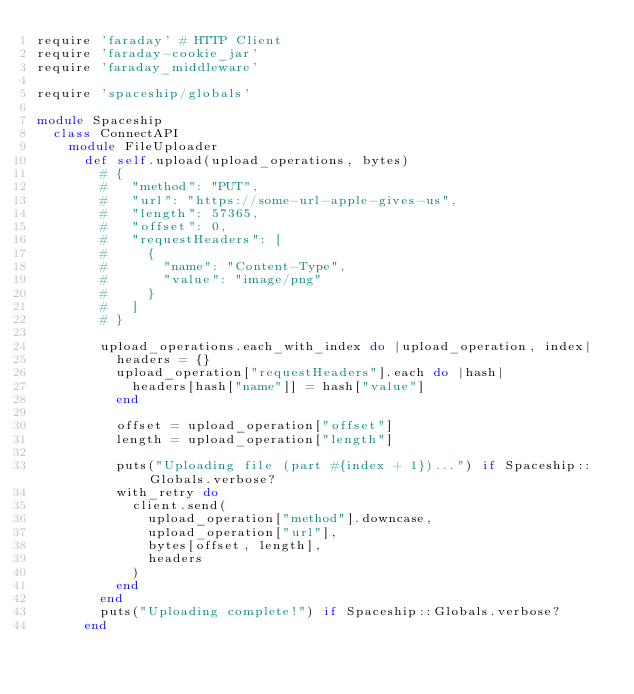<code> <loc_0><loc_0><loc_500><loc_500><_Ruby_>require 'faraday' # HTTP Client
require 'faraday-cookie_jar'
require 'faraday_middleware'

require 'spaceship/globals'

module Spaceship
  class ConnectAPI
    module FileUploader
      def self.upload(upload_operations, bytes)
        # {
        #   "method": "PUT",
        #   "url": "https://some-url-apple-gives-us",
        #   "length": 57365,
        #   "offset": 0,
        #   "requestHeaders": [
        #     {
        #       "name": "Content-Type",
        #       "value": "image/png"
        #     }
        #   ]
        # }

        upload_operations.each_with_index do |upload_operation, index|
          headers = {}
          upload_operation["requestHeaders"].each do |hash|
            headers[hash["name"]] = hash["value"]
          end

          offset = upload_operation["offset"]
          length = upload_operation["length"]

          puts("Uploading file (part #{index + 1})...") if Spaceship::Globals.verbose?
          with_retry do
            client.send(
              upload_operation["method"].downcase,
              upload_operation["url"],
              bytes[offset, length],
              headers
            )
          end
        end
        puts("Uploading complete!") if Spaceship::Globals.verbose?
      end
</code> 